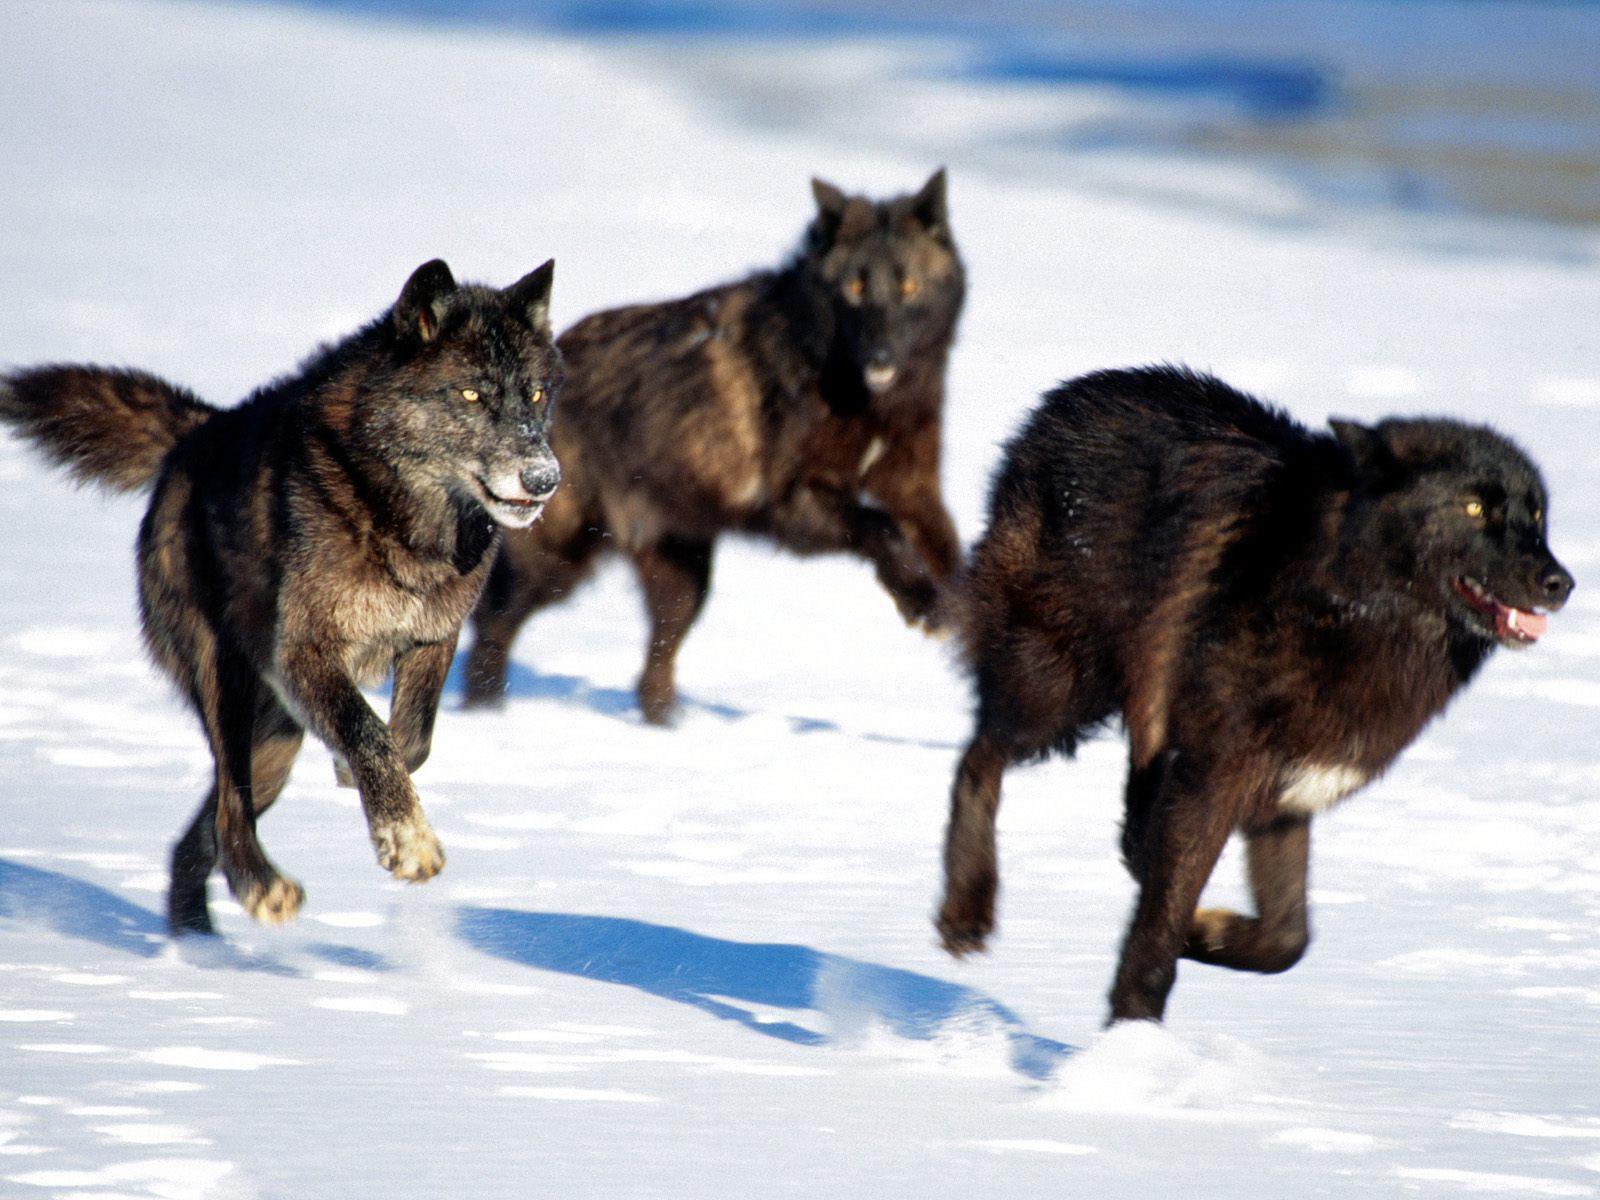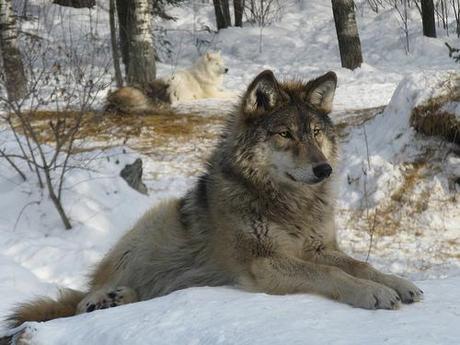The first image is the image on the left, the second image is the image on the right. Considering the images on both sides, is "Three wild dogs are in the snow in the image on the left." valid? Answer yes or no. Yes. The first image is the image on the left, the second image is the image on the right. Considering the images on both sides, is "An image shows wolves bounding across the snow." valid? Answer yes or no. Yes. 